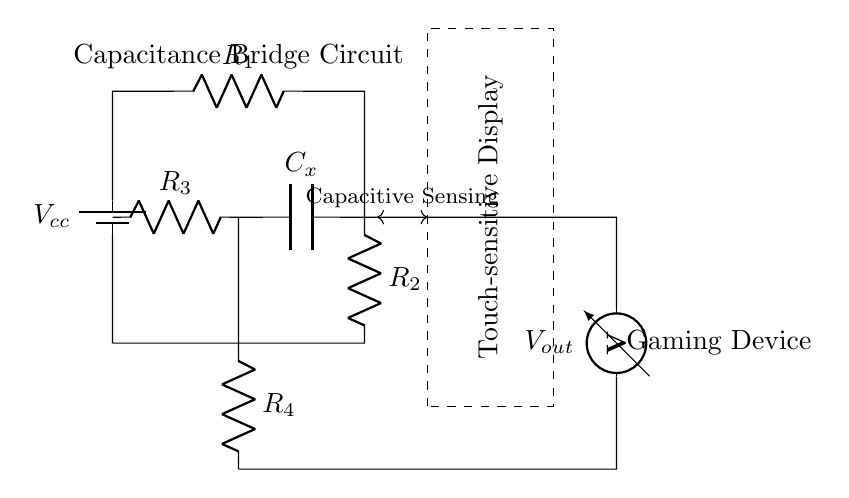What is the power supply voltage in this circuit? The power supply voltage is denoted as Vcc in the circuit diagram, indicating the input voltage from the battery source.
Answer: Vcc What types of components are utilized in the circuit? The circuit consists of resistors and a capacitor, as indicated by the labels R1, R2, R3, R4, and Cx, along with a battery for power supply.
Answer: Resistors and a capacitor What is the primary purpose of the capacitor in this circuit? The capacitor, labeled Cx, is used for the purpose of capacitive sensing in the touch-sensitive display, allowing the circuit to detect touch input.
Answer: Capacitive sensing How many resistors are present in the circuit? The circuit diagram features four resistors labeled R1, R2, R3, and R4, all contributing to the function of the capacitance bridge.
Answer: Four What is the output labeled as in the circuit? The output of the circuit is labeled as Vout, which represents the measured voltage output from the bridge circuit to the gaming device.
Answer: Vout What does the dashed rectangle represent in the circuit? The dashed rectangle represents the touch-sensitive display, indicating where input from users is detected and processed by the circuit.
Answer: Touch-sensitive Display What type of circuit configuration is depicted in the diagram? This diagram depicts a capacitance bridge circuit, which is specifically designed for comparative measurement of capacitance in touch-sensitive applications.
Answer: Capacitance bridge circuit 